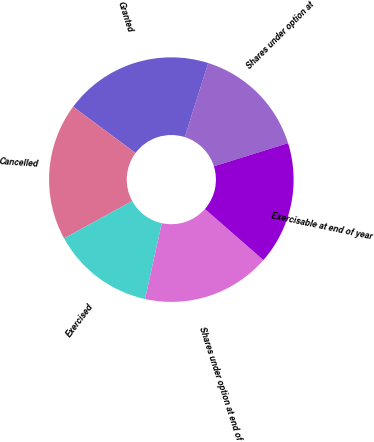Convert chart to OTSL. <chart><loc_0><loc_0><loc_500><loc_500><pie_chart><fcel>Shares under option at<fcel>Granted<fcel>Cancelled<fcel>Exercised<fcel>Shares under option at end of<fcel>Exercisable at end of year<nl><fcel>15.3%<fcel>19.71%<fcel>18.14%<fcel>13.58%<fcel>17.01%<fcel>16.25%<nl></chart> 